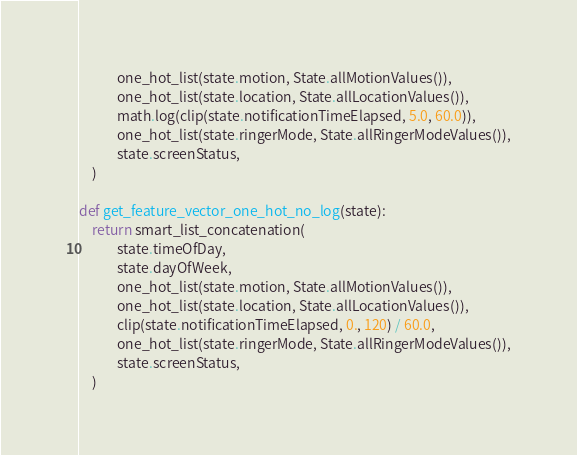Convert code to text. <code><loc_0><loc_0><loc_500><loc_500><_Python_>			one_hot_list(state.motion, State.allMotionValues()),
			one_hot_list(state.location, State.allLocationValues()),
			math.log(clip(state.notificationTimeElapsed, 5.0, 60.0)),
			one_hot_list(state.ringerMode, State.allRingerModeValues()),
			state.screenStatus,
	)

def get_feature_vector_one_hot_no_log(state):
	return smart_list_concatenation(
			state.timeOfDay,
			state.dayOfWeek,
			one_hot_list(state.motion, State.allMotionValues()),
			one_hot_list(state.location, State.allLocationValues()),
			clip(state.notificationTimeElapsed, 0., 120) / 60.0,
			one_hot_list(state.ringerMode, State.allRingerModeValues()),
			state.screenStatus,
	)
</code> 